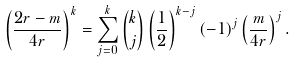Convert formula to latex. <formula><loc_0><loc_0><loc_500><loc_500>\left ( \frac { 2 r - m } { 4 r } \right ) ^ { k } = \sum _ { j = 0 } ^ { k } \binom { k } { j } \left ( \frac { 1 } 2 \right ) ^ { k - j } ( - 1 ) ^ { j } \left ( \frac { m } { 4 r } \right ) ^ { j } .</formula> 